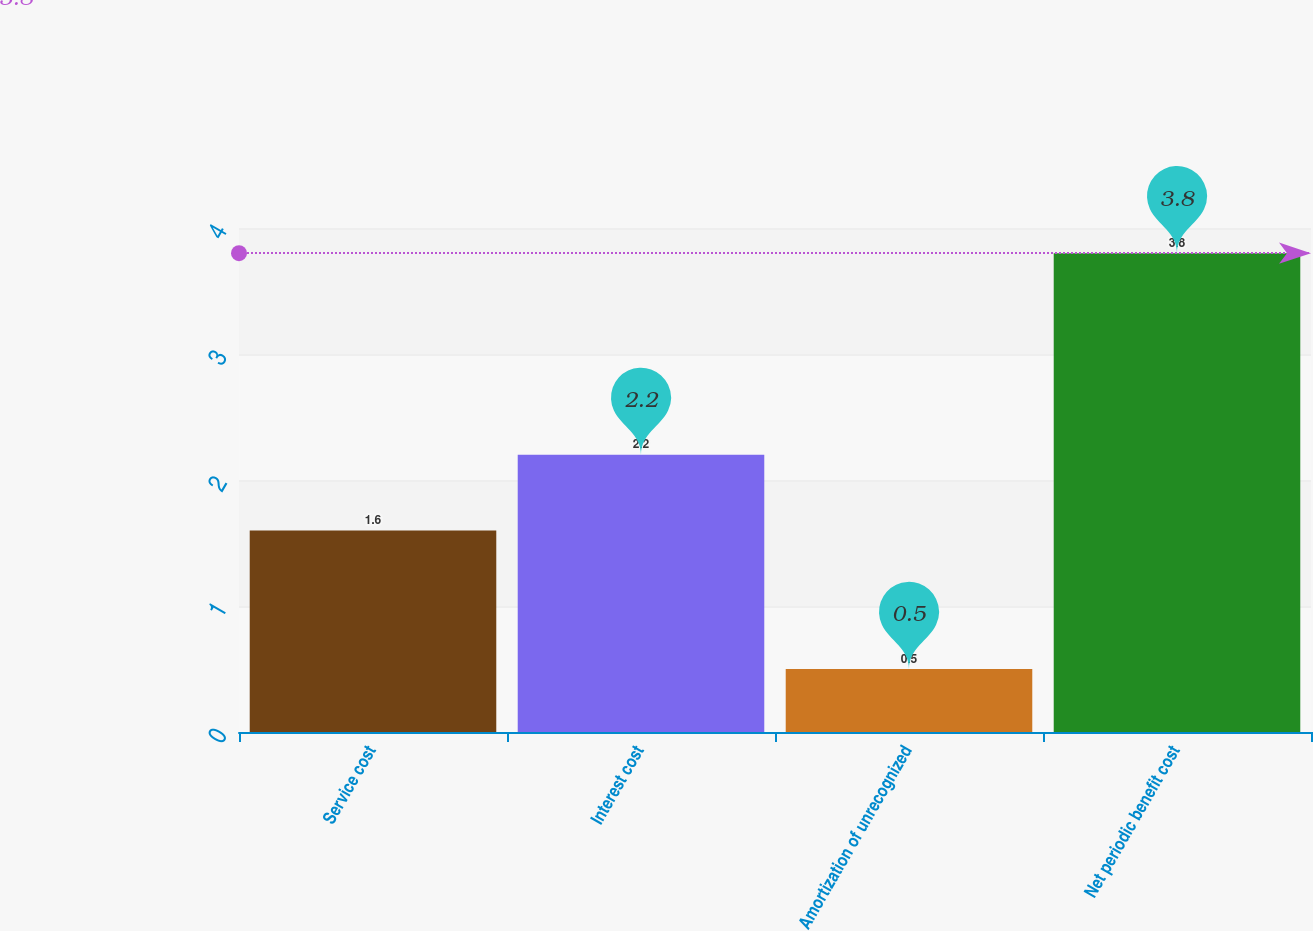Convert chart. <chart><loc_0><loc_0><loc_500><loc_500><bar_chart><fcel>Service cost<fcel>Interest cost<fcel>Amortization of unrecognized<fcel>Net periodic benefit cost<nl><fcel>1.6<fcel>2.2<fcel>0.5<fcel>3.8<nl></chart> 